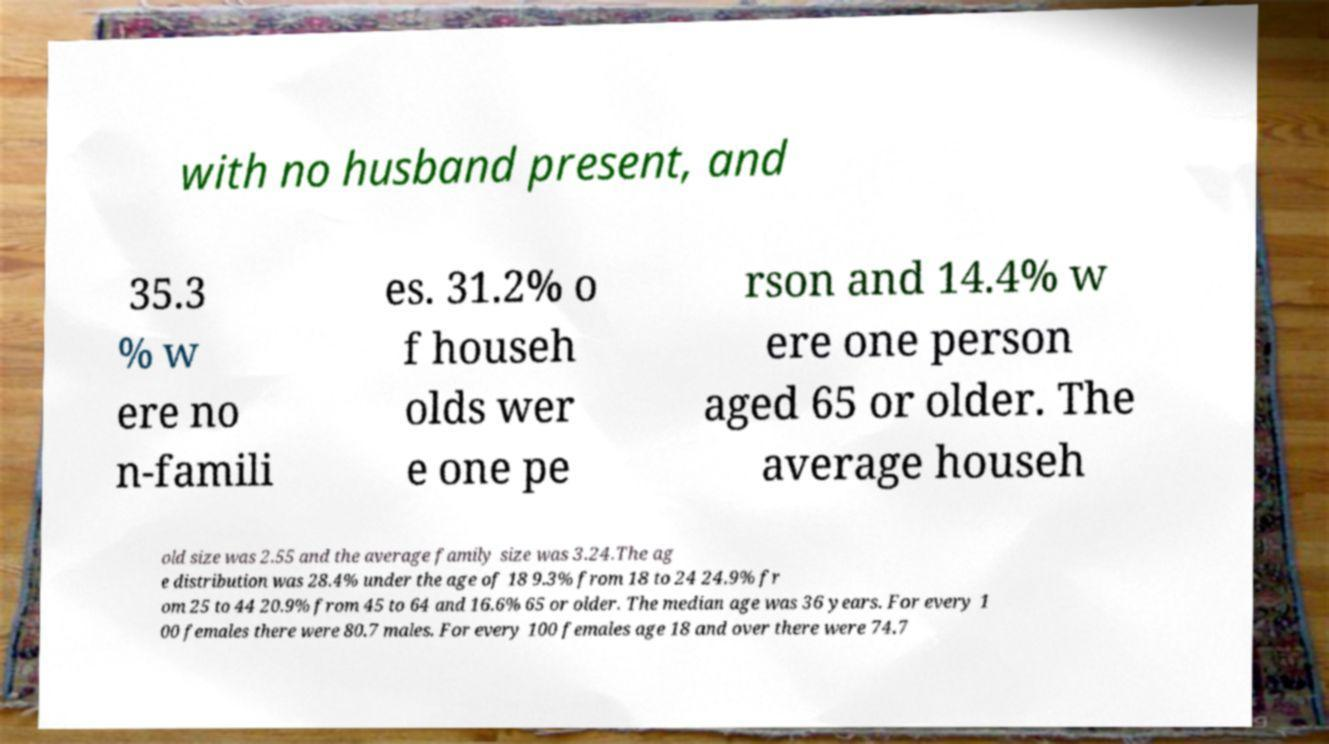Can you read and provide the text displayed in the image?This photo seems to have some interesting text. Can you extract and type it out for me? with no husband present, and 35.3 % w ere no n-famili es. 31.2% o f househ olds wer e one pe rson and 14.4% w ere one person aged 65 or older. The average househ old size was 2.55 and the average family size was 3.24.The ag e distribution was 28.4% under the age of 18 9.3% from 18 to 24 24.9% fr om 25 to 44 20.9% from 45 to 64 and 16.6% 65 or older. The median age was 36 years. For every 1 00 females there were 80.7 males. For every 100 females age 18 and over there were 74.7 